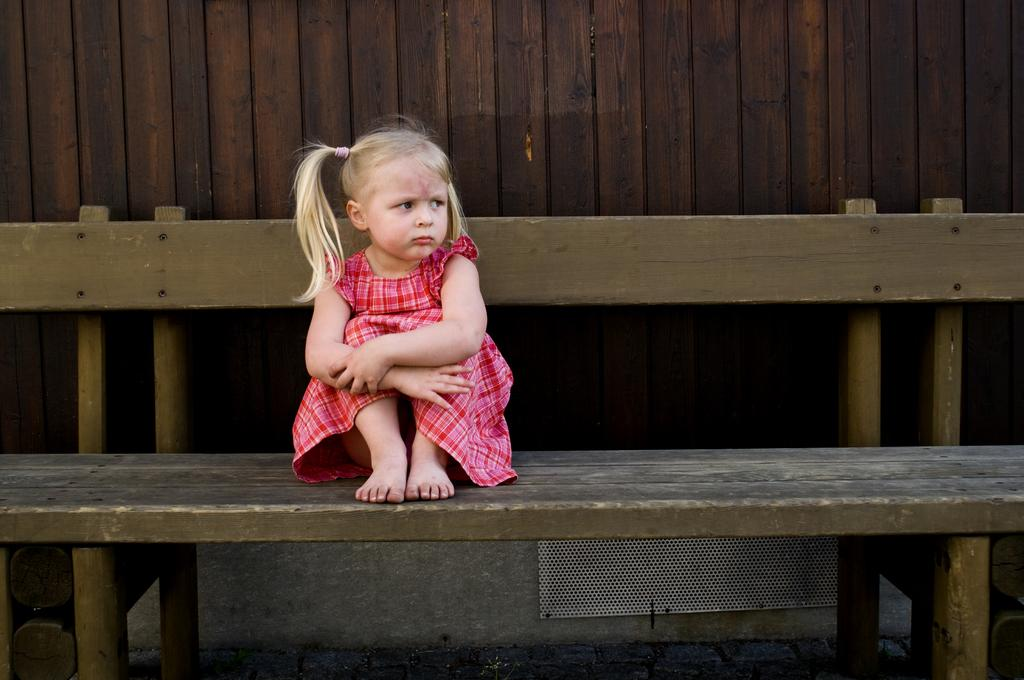What is the main subject of the image? The main subject of the image is a kid. What is the kid wearing in the image? The kid is wearing a red frock in the image. What is the kid doing in the image? The kid is sitting on a bench in the image. What type of plants can be seen growing in the lake in the image? There is no lake or plants present in the image; it features a kid sitting on a bench while wearing a red frock. 